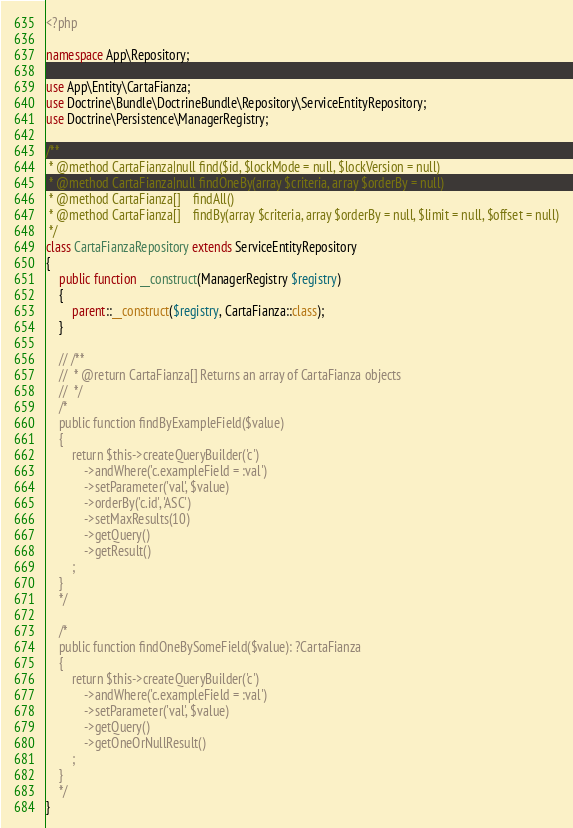Convert code to text. <code><loc_0><loc_0><loc_500><loc_500><_PHP_><?php

namespace App\Repository;

use App\Entity\CartaFianza;
use Doctrine\Bundle\DoctrineBundle\Repository\ServiceEntityRepository;
use Doctrine\Persistence\ManagerRegistry;

/**
 * @method CartaFianza|null find($id, $lockMode = null, $lockVersion = null)
 * @method CartaFianza|null findOneBy(array $criteria, array $orderBy = null)
 * @method CartaFianza[]    findAll()
 * @method CartaFianza[]    findBy(array $criteria, array $orderBy = null, $limit = null, $offset = null)
 */
class CartaFianzaRepository extends ServiceEntityRepository
{
    public function __construct(ManagerRegistry $registry)
    {
        parent::__construct($registry, CartaFianza::class);
    }

    // /**
    //  * @return CartaFianza[] Returns an array of CartaFianza objects
    //  */
    /*
    public function findByExampleField($value)
    {
        return $this->createQueryBuilder('c')
            ->andWhere('c.exampleField = :val')
            ->setParameter('val', $value)
            ->orderBy('c.id', 'ASC')
            ->setMaxResults(10)
            ->getQuery()
            ->getResult()
        ;
    }
    */

    /*
    public function findOneBySomeField($value): ?CartaFianza
    {
        return $this->createQueryBuilder('c')
            ->andWhere('c.exampleField = :val')
            ->setParameter('val', $value)
            ->getQuery()
            ->getOneOrNullResult()
        ;
    }
    */
}
</code> 